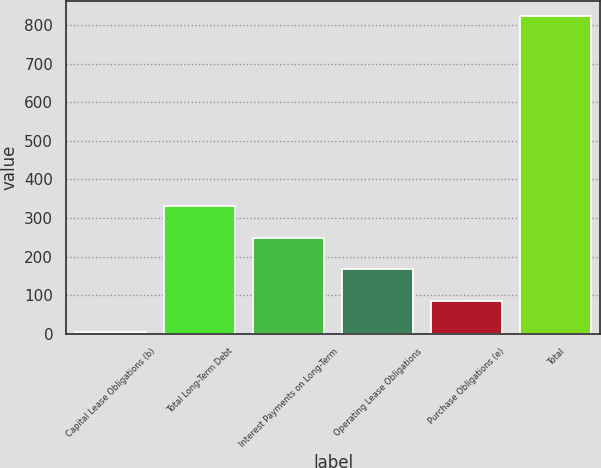Convert chart to OTSL. <chart><loc_0><loc_0><loc_500><loc_500><bar_chart><fcel>Capital Lease Obligations (b)<fcel>Total Long-Term Debt<fcel>Interest Payments on Long-Term<fcel>Operating Lease Obligations<fcel>Purchase Obligations (e)<fcel>Total<nl><fcel>3<fcel>331.04<fcel>249.03<fcel>167.02<fcel>85.01<fcel>823.1<nl></chart> 